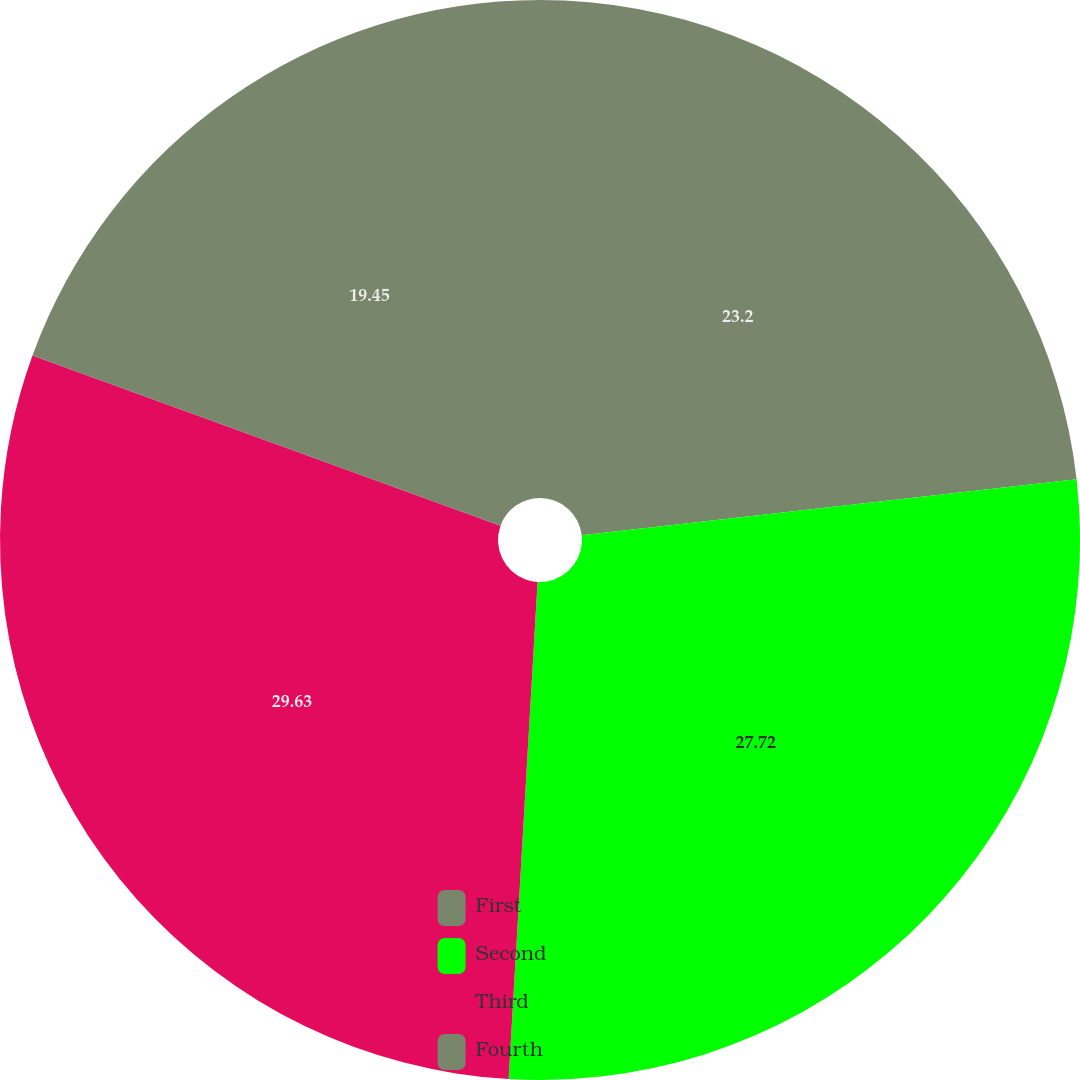Convert chart to OTSL. <chart><loc_0><loc_0><loc_500><loc_500><pie_chart><fcel>First<fcel>Second<fcel>Third<fcel>Fourth<nl><fcel>23.2%<fcel>27.72%<fcel>29.62%<fcel>19.45%<nl></chart> 